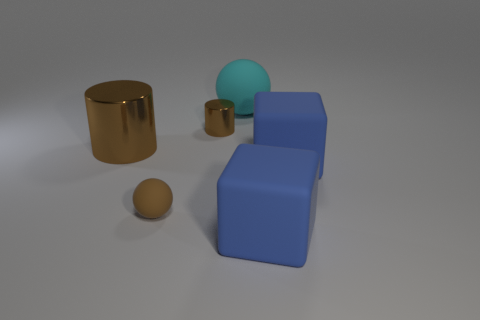Add 3 small brown cylinders. How many objects exist? 9 Subtract all big rubber spheres. Subtract all green cubes. How many objects are left? 5 Add 1 cyan matte spheres. How many cyan matte spheres are left? 2 Add 1 tiny blue rubber objects. How many tiny blue rubber objects exist? 1 Subtract 0 green cylinders. How many objects are left? 6 